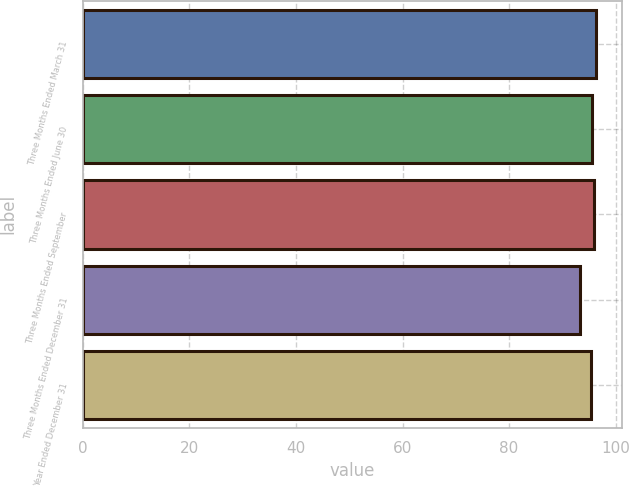Convert chart to OTSL. <chart><loc_0><loc_0><loc_500><loc_500><bar_chart><fcel>Three Months Ended March 31<fcel>Three Months Ended June 30<fcel>Three Months Ended September<fcel>Three Months Ended December 31<fcel>Year Ended December 31<nl><fcel>96.3<fcel>95.6<fcel>95.89<fcel>93.4<fcel>95.3<nl></chart> 